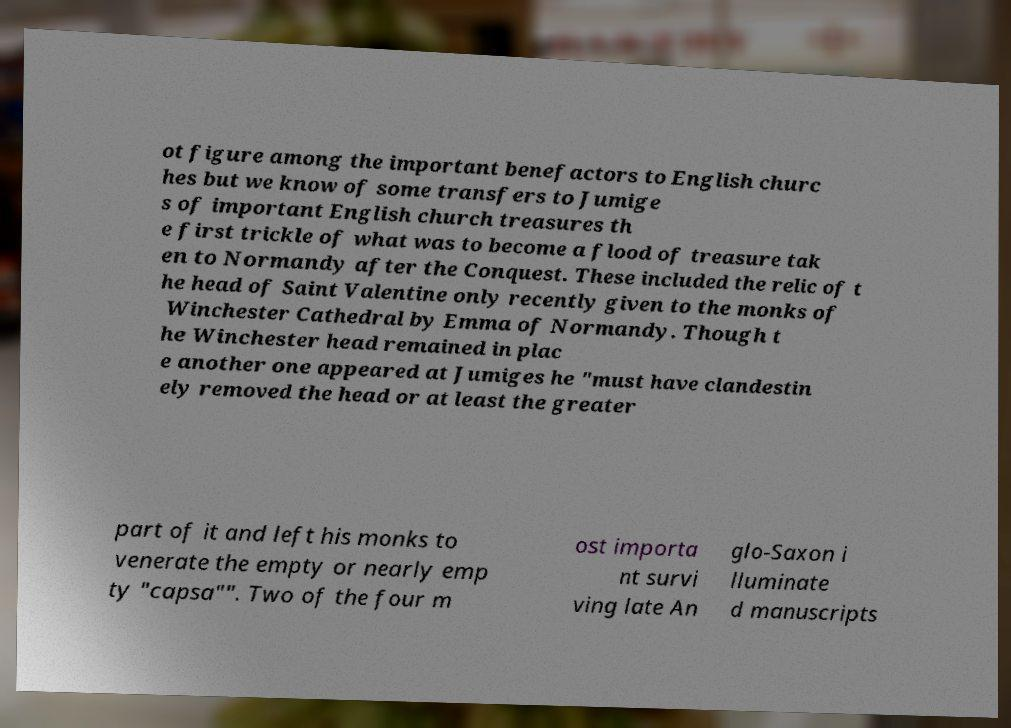Please read and relay the text visible in this image. What does it say? ot figure among the important benefactors to English churc hes but we know of some transfers to Jumige s of important English church treasures th e first trickle of what was to become a flood of treasure tak en to Normandy after the Conquest. These included the relic of t he head of Saint Valentine only recently given to the monks of Winchester Cathedral by Emma of Normandy. Though t he Winchester head remained in plac e another one appeared at Jumiges he "must have clandestin ely removed the head or at least the greater part of it and left his monks to venerate the empty or nearly emp ty "capsa"". Two of the four m ost importa nt survi ving late An glo-Saxon i lluminate d manuscripts 